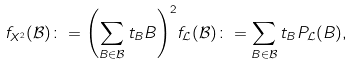Convert formula to latex. <formula><loc_0><loc_0><loc_500><loc_500>f _ { X ^ { 2 } } ( \mathcal { B } ) \colon = { \left ( \sum _ { B \in \mathcal { B } } t _ { B } B \right ) } ^ { 2 } f _ { \mathcal { L } } ( \mathcal { B } ) \colon = \sum _ { B \in \mathcal { B } } t _ { B } P _ { \mathcal { L } } ( B ) ,</formula> 